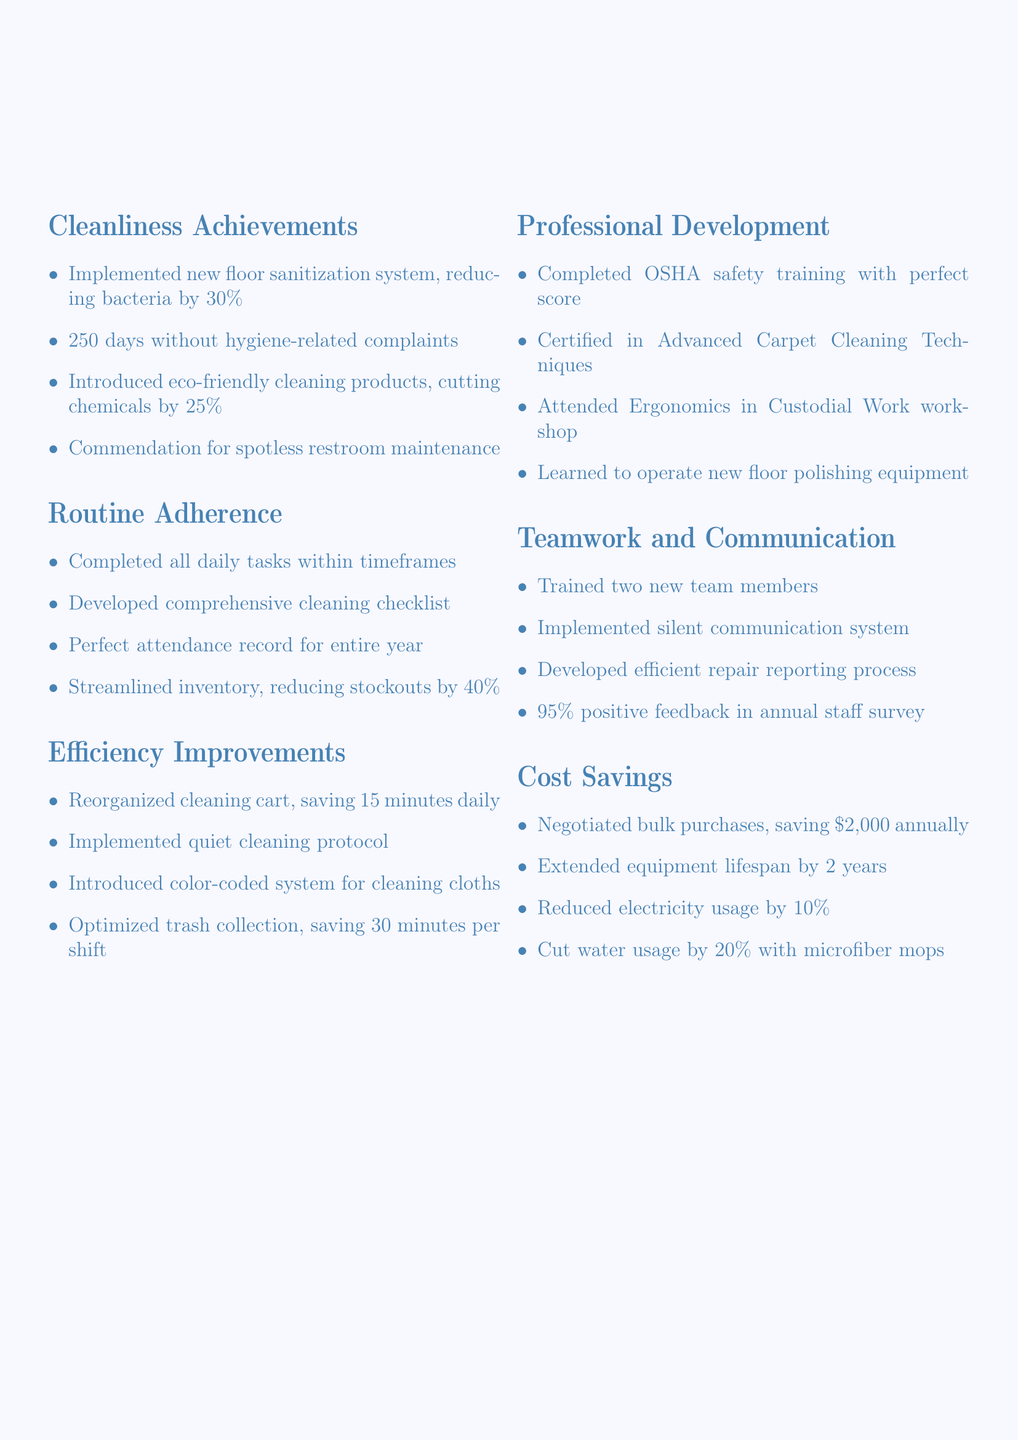What is the bacteria reduction percentage from the new floor sanitization system? The document states that the new floor sanitization system reduced bacteria levels by 30%.
Answer: 30% How many days were maintained without hygiene-related complaints? According to the document, there was a streak of 250 days without any hygiene-related complaints.
Answer: 250 days What certification was obtained related to advanced cleaning techniques? The document mentions that a certification in Advanced Carpet Cleaning Techniques was obtained.
Answer: Advanced Carpet Cleaning Techniques What was the percentage of positive feedback from office staff in the annual survey? The document indicates that 95% of office staff provided positive feedback in the annual survey.
Answer: 95% How much money was saved annually through negotiating bulk purchases? The document states that negotiating bulk purchase deals with suppliers saved $2,000 annually.
Answer: $2,000 What is the total percentage cut in chemical usage due to eco-friendly products? The document mentions that the introduction of eco-friendly cleaning products cut chemical usage by 25%.
Answer: 25% How many new team members were trained on cleaning procedures? According to the document, two new team members were trained on proper cleaning procedures.
Answer: Two team members What system was implemented for quiet communication during cleaning hours? The document states that a silent communication system using hand signals was implemented during quiet hours.
Answer: Silent communication system What was the percentage reduction in stockouts achieved through inventory streamlining? The document notes that a streamlined supply inventory process reduced stockouts by 40%.
Answer: 40% 